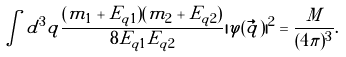<formula> <loc_0><loc_0><loc_500><loc_500>\int d ^ { 3 } q \frac { ( m _ { 1 } + E _ { q 1 } ) ( m _ { 2 } + E _ { q 2 } ) } { 8 E _ { q 1 } E _ { q 2 } } | \varphi ( { \vec { q } } ) | ^ { 2 } = \frac { M } { ( 4 \pi ) ^ { 3 } } .</formula> 